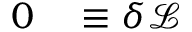<formula> <loc_0><loc_0><loc_500><loc_500>\begin{array} { r l } { 0 } & \equiv \delta { \mathcal { L } } } \end{array}</formula> 